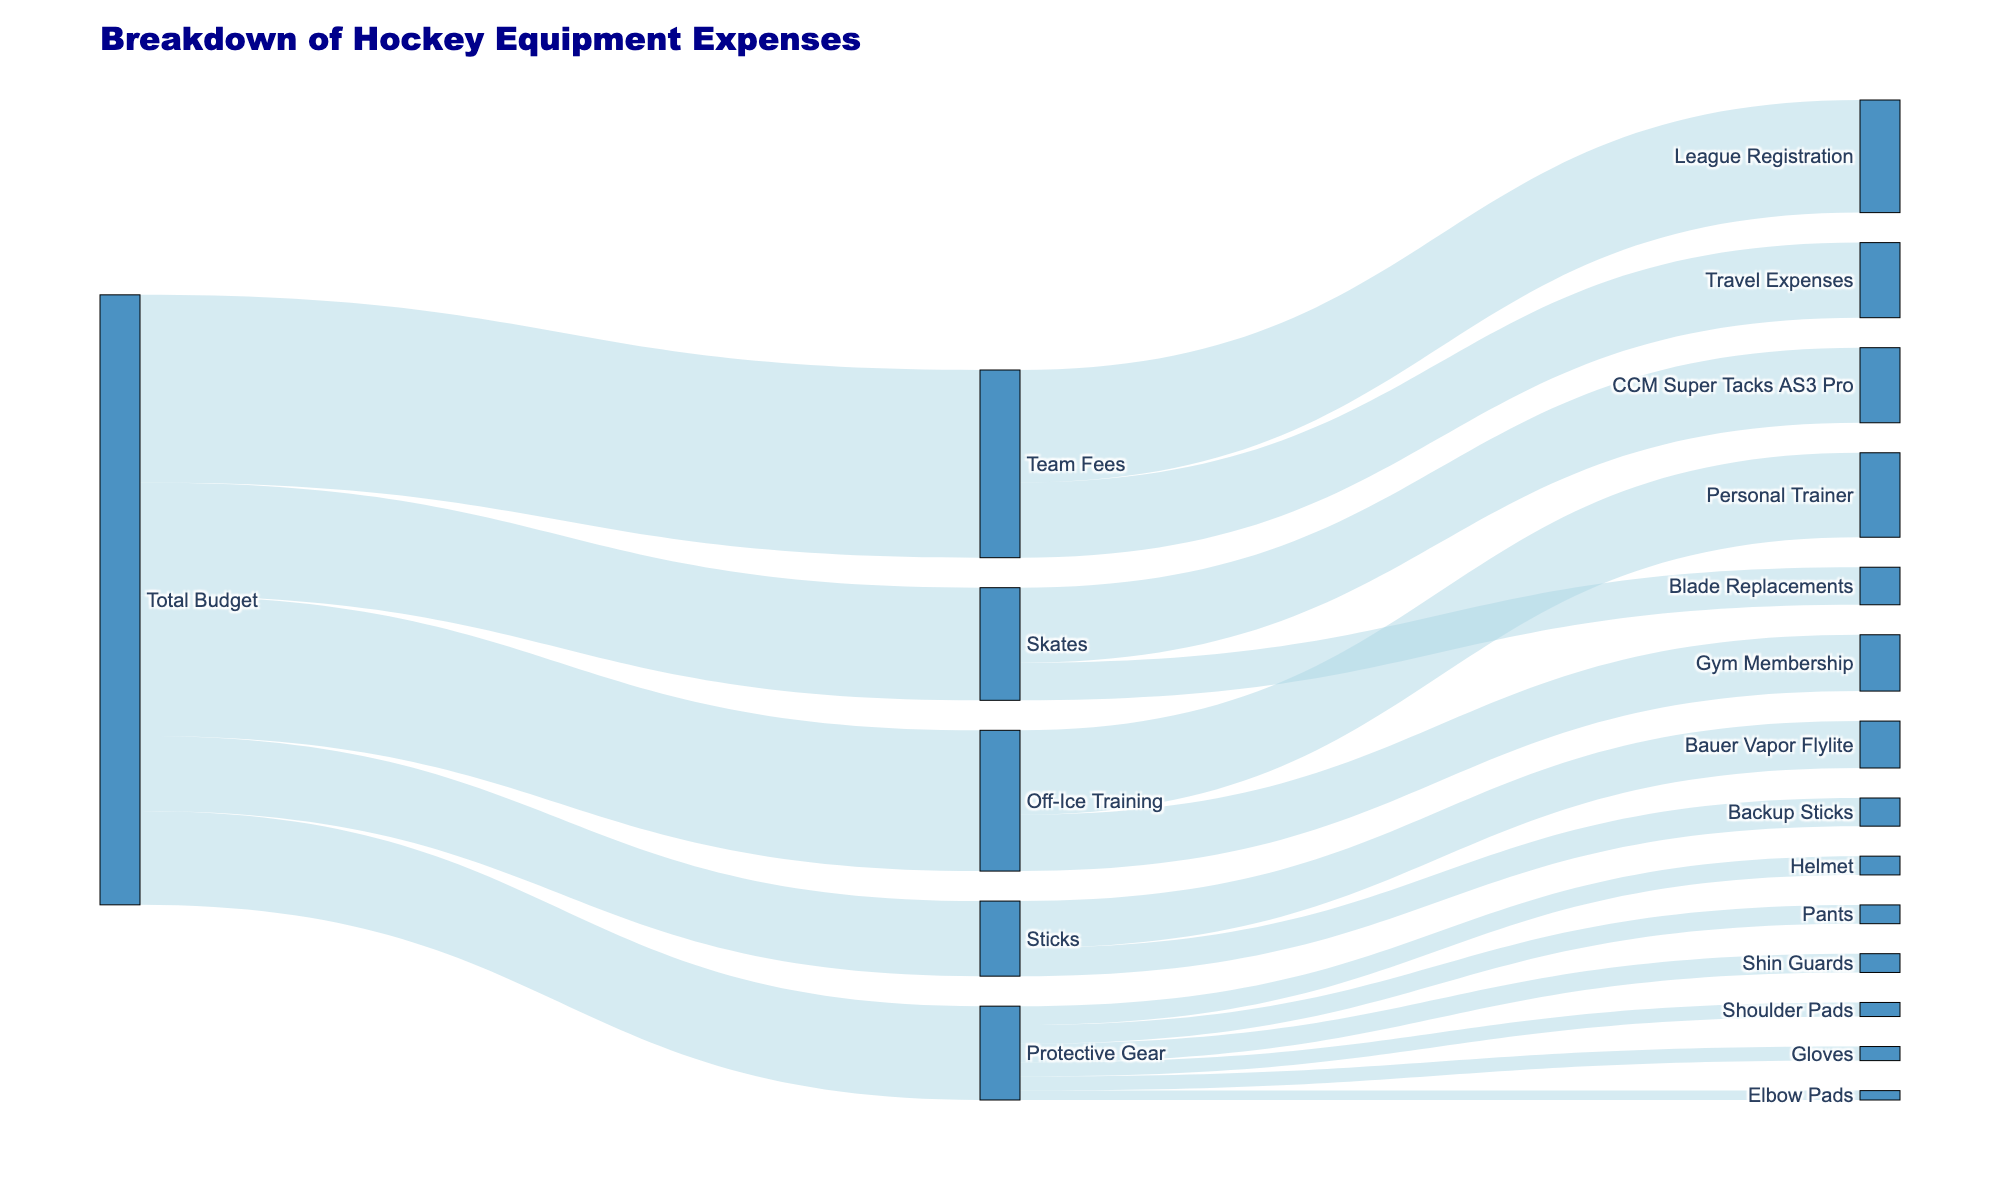What is the title of the diagram? The title can be found at the top of the diagram and is the largest text, centered.
Answer: Breakdown of Hockey Equipment Expenses How much of the total budget is allocated to sticks? Look at the section of the diagram where "Total Budget" splits into several categories; one of these categories is "Sticks." The value is next to this category.
Answer: 800 What subcategory under "Off-Ice Training" has the highest expense? Follow the branch from "Off-Ice Training" and see the values for its subcategories: "Gym Membership" and "Personal Trainer." Compare their values.
Answer: Personal Trainer How much is spent on "Protective Gear" in total? Identify all subcategories of "Protective Gear" and sum their values: Helmet (200), Shoulder Pads (150), Elbow Pads (100), Gloves (150), Pants (200), and Shin Guards (200). The calculations would be 200+150+100+150+200+200.
Answer: 1000 Which category, "Skates" or "Team Fees," has the larger expense? Compare the values allocated to "Skates" and "Team Fees" under "Total Budget."
Answer: Team Fees How much does the "CCM Super Tacks AS3 Pro" skates cost? Locate the branch labeled "Skates," then identify the subsection labeled "CCM Super Tacks AS3 Pro," and check its value.
Answer: 800 What is the combined expense for "Blade Replacements" and "Backup Sticks"? Locate the values for "Blade Replacements" and "Backup Sticks," then add them together: Blade Replacements (400) and Backup Sticks (300).
Answer: 700 Which has a higher expense: "Gym Membership" or "League Registration"? Compare the value of "Gym Membership" under "Off-Ice Training" with "League Registration" under "Team Fees."
Answer: League Registration What is the total expense for "Travel Expenses" under "Team Fees"? Find the value of "Travel Expenses" within the "Team Fees" category in the diagram.
Answer: 800 Which brand of skates is more expensive: "CCM Super Tacks AS3 Pro" or "Blade Replacements"? Compare the cost values next to "CCM Super Tacks AS3 Pro" and "Blade Replacements" under the "Skates" section.
Answer: CCM Super Tacks AS3 Pro 